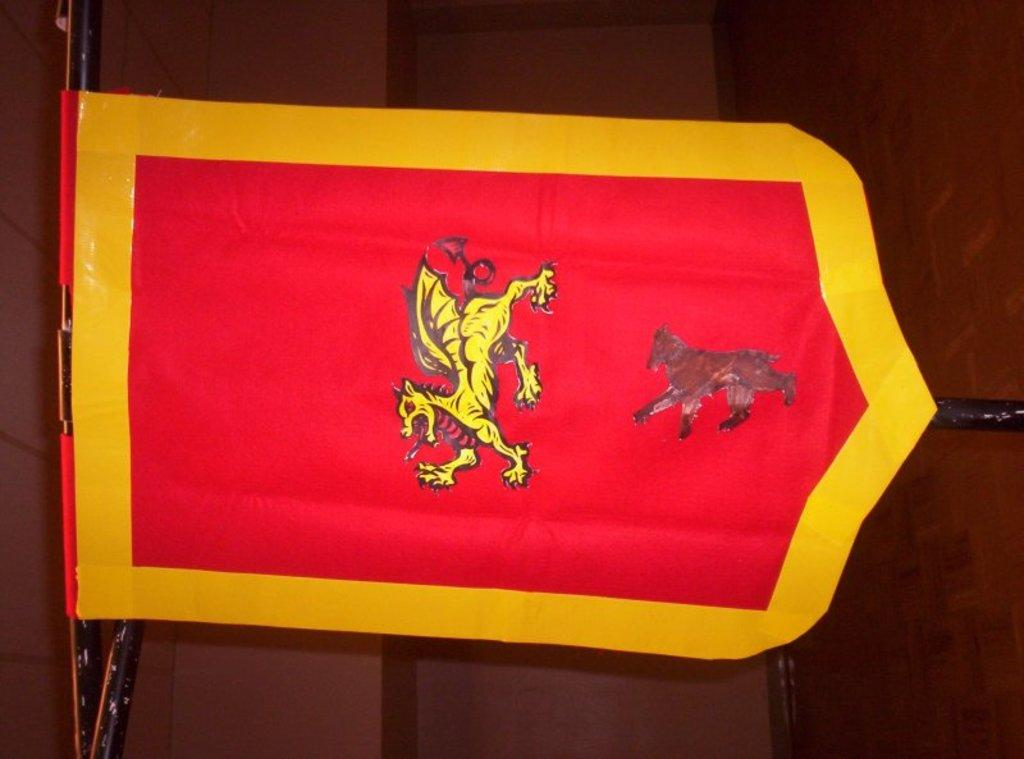What is the main object in the image? There is a flag in the image. Can you describe the flag's design? The flag has yellow borders and a red image of a dragon in the middle. What is located behind the flag in the image? There is a wall behind the flag in the image. What type of grape is being played by the band in the image? There is no grape or band present in the image; it only features a flag with a dragon design. What shape is the dragon on the flag? The provided facts do not mention the shape of the dragon on the flag, only its color. 